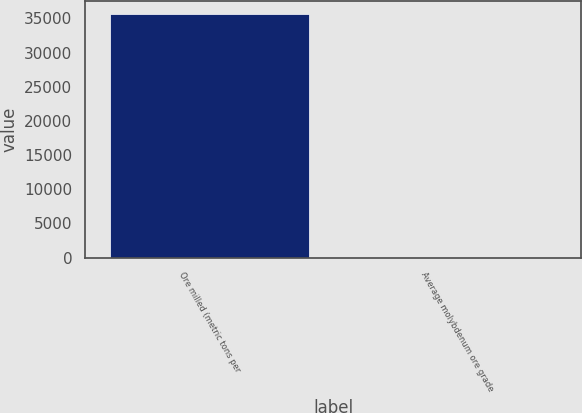Convert chart. <chart><loc_0><loc_0><loc_500><loc_500><bar_chart><fcel>Ore milled (metric tons per<fcel>Average molybdenum ore grade<nl><fcel>35700<fcel>0.19<nl></chart> 